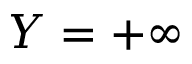<formula> <loc_0><loc_0><loc_500><loc_500>Y = + \infty</formula> 